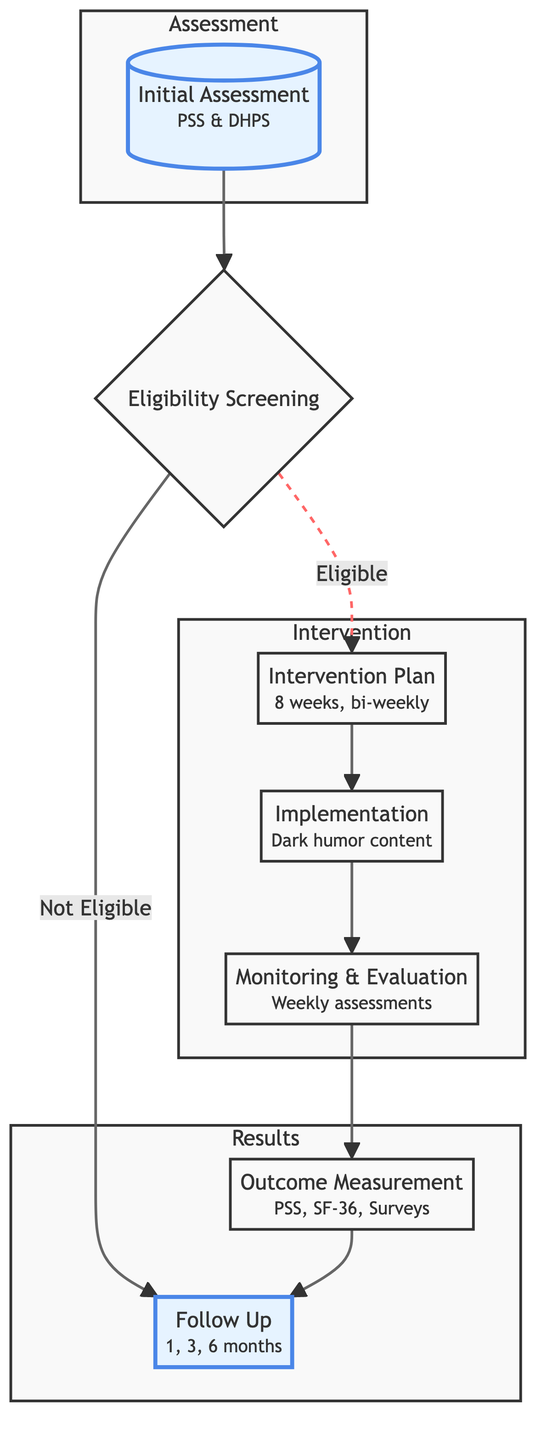What is the first step in the clinical pathway? The clinical pathway begins with the "Initial Assessment" step, where patients' baseline stress levels and attitudes towards dark humor are evaluated. This is the starting point identified in the diagram.
Answer: Initial Assessment How long does the implementation phase last? The implementation phase is specified to last for "8 weeks" according to the details provided in the diagram.
Answer: 8 weeks What happens if a patient is not eligible in the eligibility screening? If a patient is not eligible during the eligibility screening, they proceed directly to the "Follow Up" phase, which is outlined in the diagram as the next step for ineligible patients.
Answer: Follow Up How often are the sessions implemented during the intervention phase? The diagram states that the intervention sessions occur bi-weekly, which indicates that the sessions are held every two weeks during the implementation.
Answer: Bi-weekly What assessment tools are used during the initial assessment? During the initial assessment, the specified assessment tools mentioned in the diagram include the "Perceived Stress Scale (PSS)" and the "Dark Humor Processing Scale (DHPS)."
Answer: PSS, DHPS What is monitored weekly during the monitoring and evaluation phase? The diagram indicates that "weekly stress level assessments" are monitored during the monitoring and evaluation phase, allowing for tracking of patient progress.
Answer: Weekly stress level assessments How many months after the intervention does the first follow-up occur? The first follow-up occurs "1 month" post-intervention, as described in the follow-up section of the diagram.
Answer: 1 month What type of content is administered during the implementation phase? The implementation phase revolves around "Dark humor content" that is curated and administered during the therapy sessions, as shown in the diagram.
Answer: Dark humor content What metrics are used for outcome measurement? The metrics outlined for outcome measurement include "Post-intervention PSS scores," "Quality of Life assessments (e.g., SF-36)," and "Patient satisfaction surveys," as per the details in the diagram.
Answer: PSS scores, SF-36, Patient satisfaction surveys 